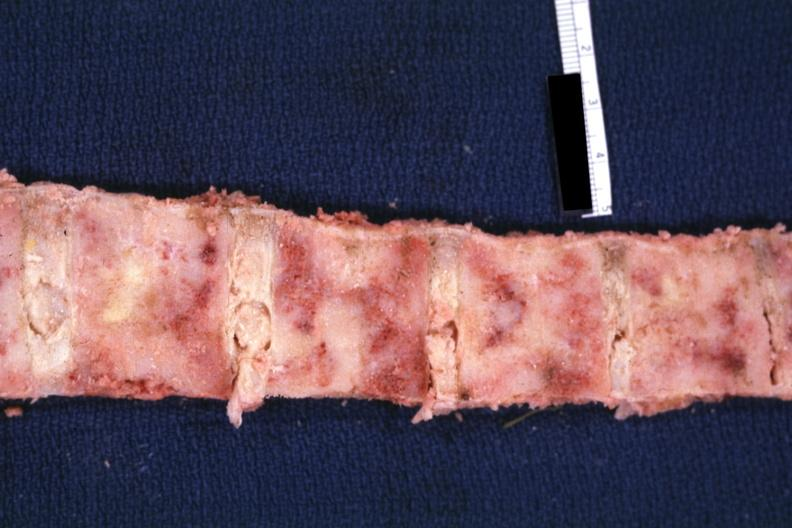s bone nearly completely filled with tumor primary lung?
Answer the question using a single word or phrase. Yes 